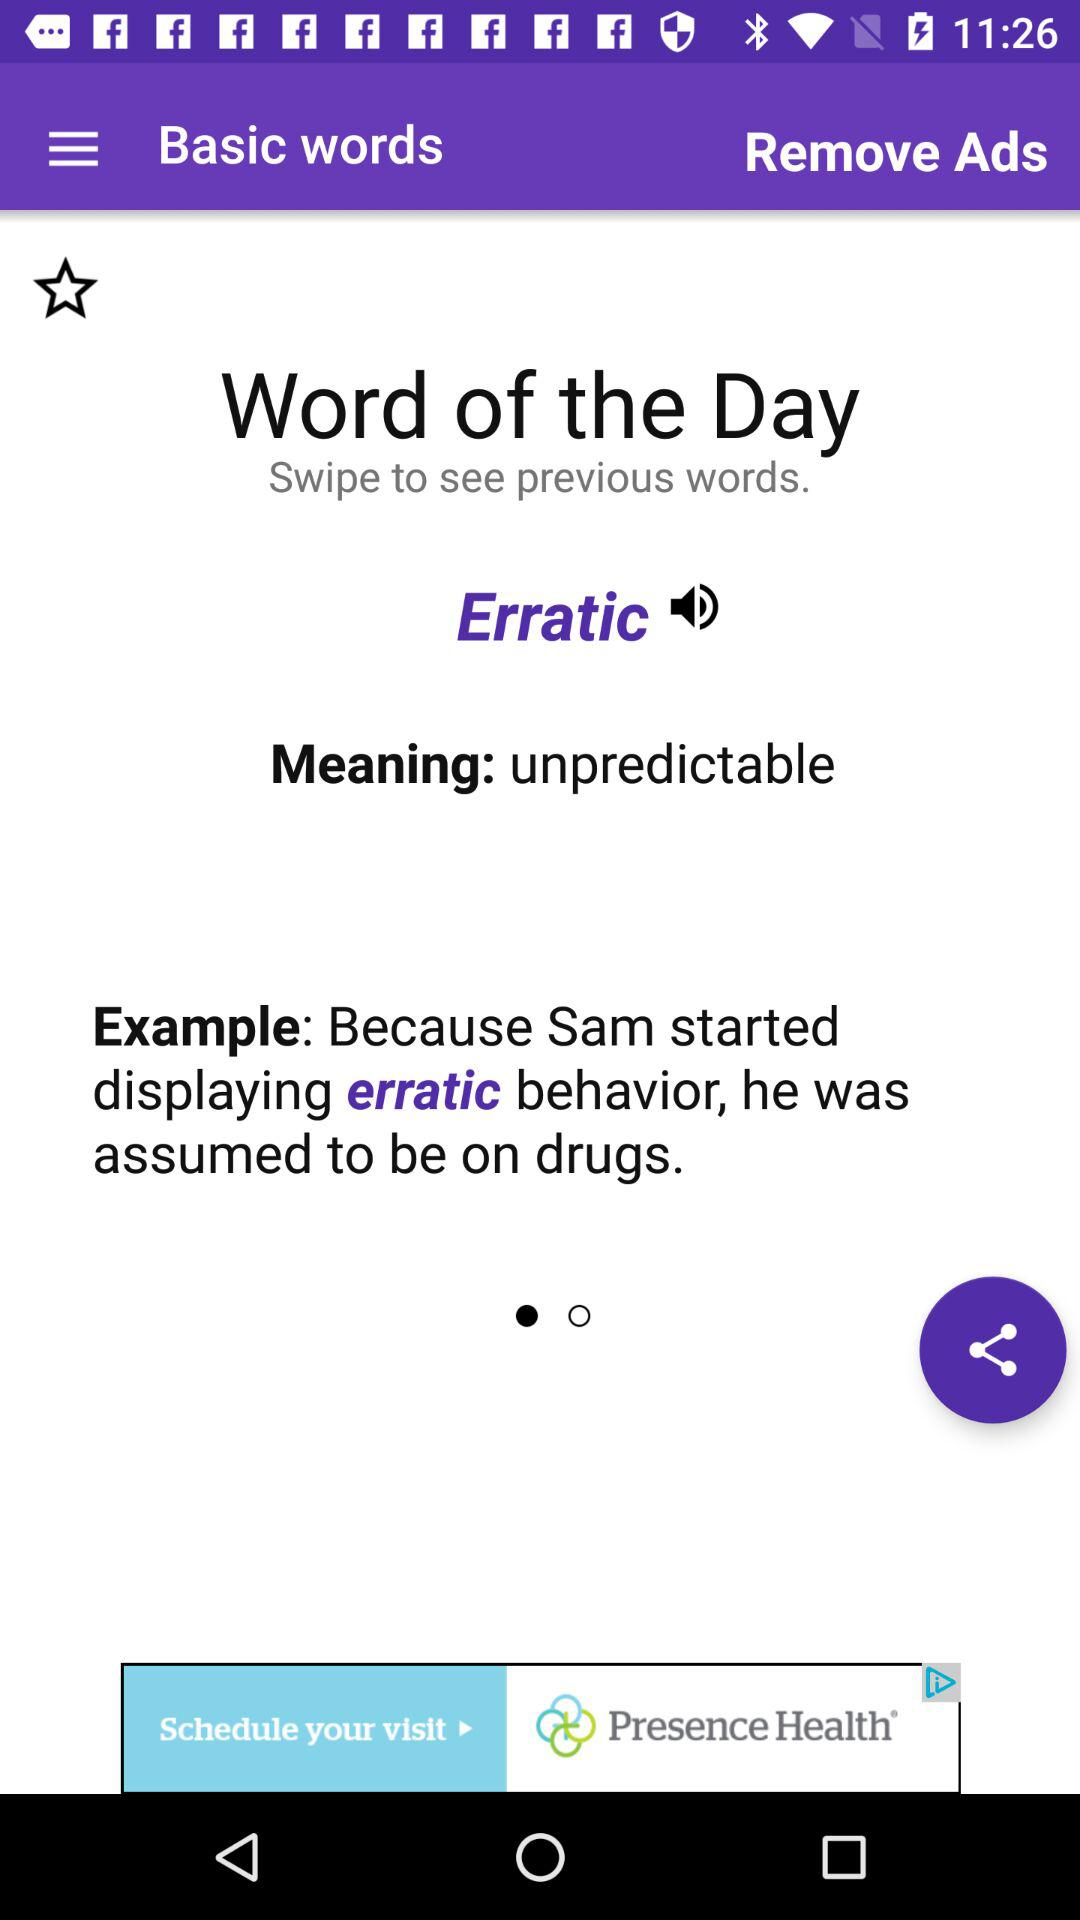What is the example for "Erratic"? The example is "Because Sam started displaying erratic behavior, he was assumed to be on drugs". 